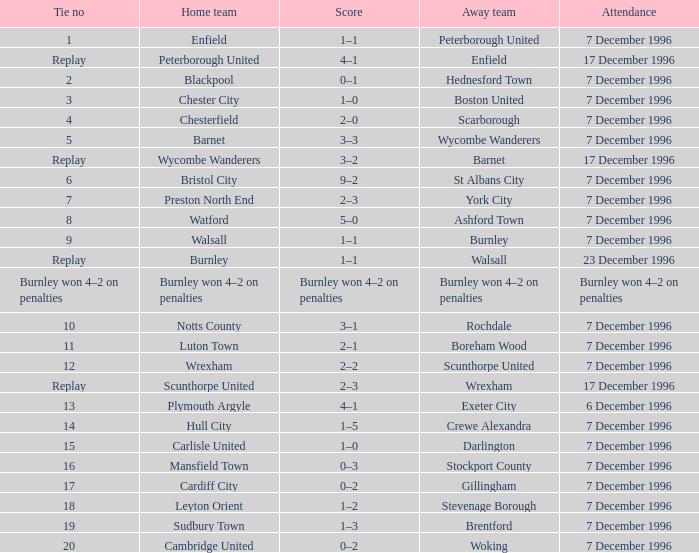What was the score of tie number 15? 1–0. 